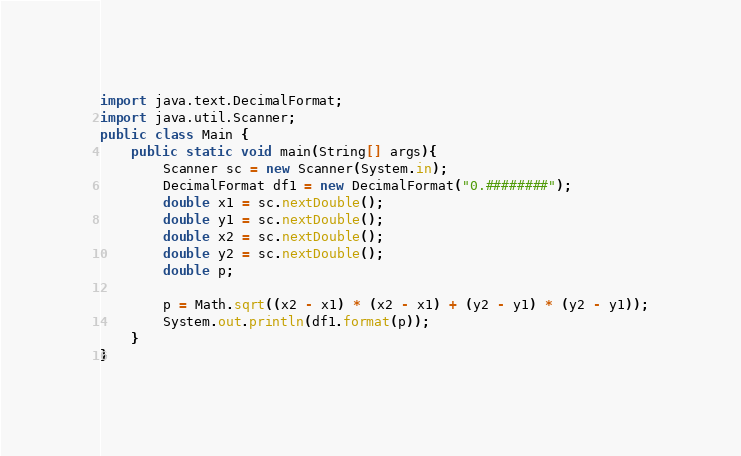<code> <loc_0><loc_0><loc_500><loc_500><_Java_>import java.text.DecimalFormat;
import java.util.Scanner;
public class Main {
	public static void main(String[] args){
		Scanner sc = new Scanner(System.in);
		DecimalFormat df1 = new DecimalFormat("0.########");
		double x1 = sc.nextDouble();
		double y1 = sc.nextDouble();
		double x2 = sc.nextDouble();
		double y2 = sc.nextDouble();
		double p;
		
		p = Math.sqrt((x2 - x1) * (x2 - x1) + (y2 - y1) * (y2 - y1));
		System.out.println(df1.format(p));
	}
}
</code> 